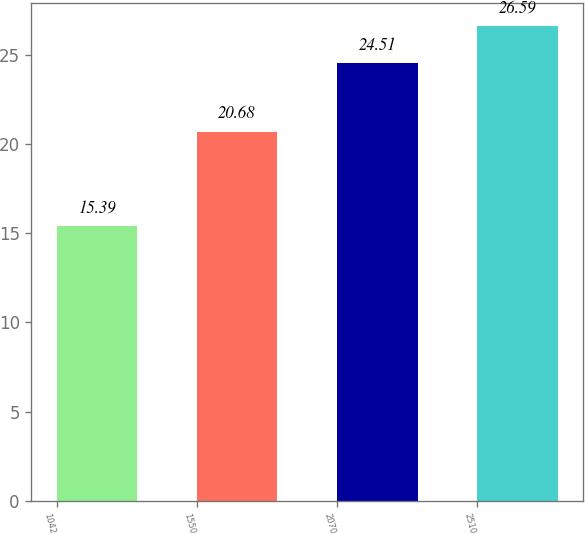Convert chart to OTSL. <chart><loc_0><loc_0><loc_500><loc_500><bar_chart><fcel>1042<fcel>1550<fcel>2070<fcel>2510<nl><fcel>15.39<fcel>20.68<fcel>24.51<fcel>26.59<nl></chart> 